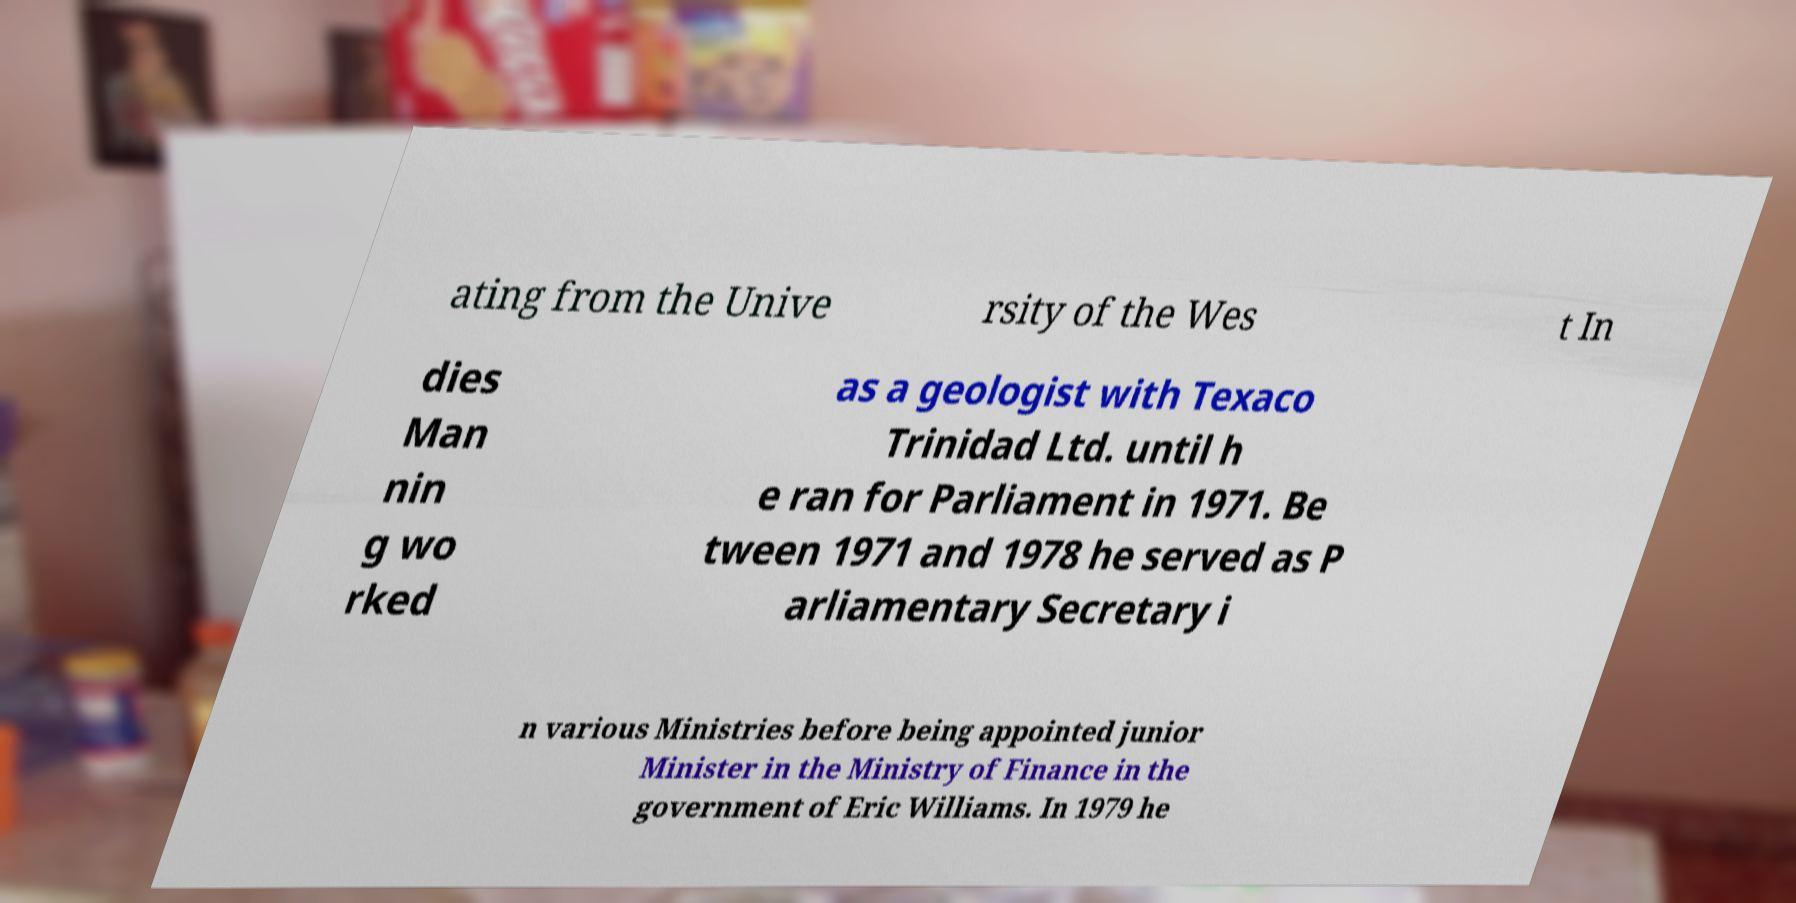For documentation purposes, I need the text within this image transcribed. Could you provide that? ating from the Unive rsity of the Wes t In dies Man nin g wo rked as a geologist with Texaco Trinidad Ltd. until h e ran for Parliament in 1971. Be tween 1971 and 1978 he served as P arliamentary Secretary i n various Ministries before being appointed junior Minister in the Ministry of Finance in the government of Eric Williams. In 1979 he 